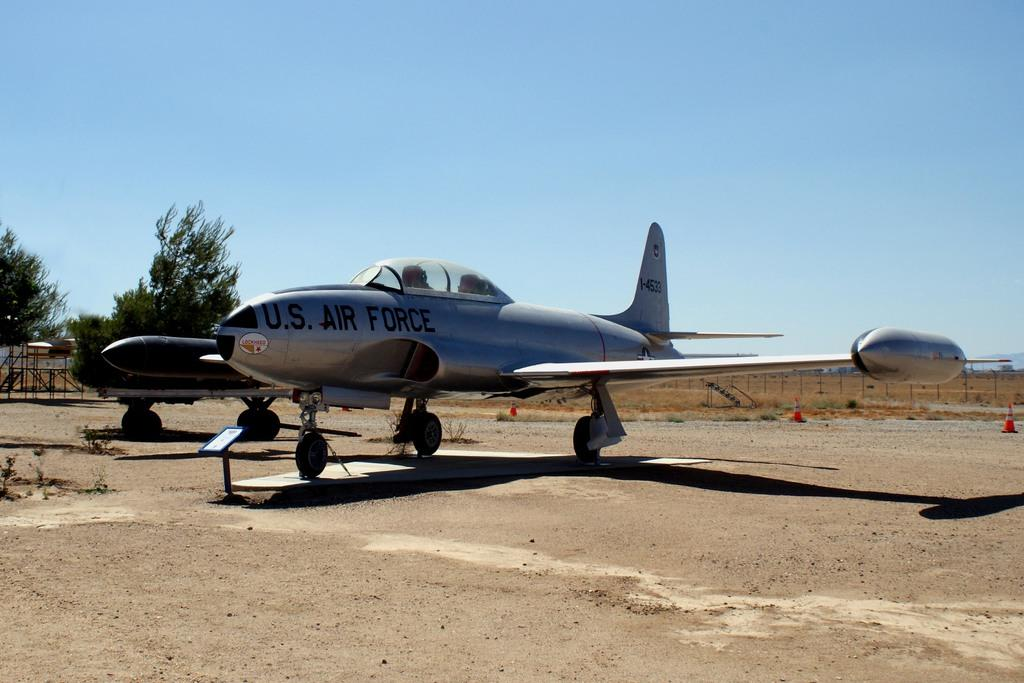Where was the image taken? The image is clicked outside. What is the main subject of the image? The main subject of the image is an airplane. What are the features of the airplane in the image? The airplane has wings, wheels, and a propeller. What can be seen on the left side of the image? There are trees on the left side of the image. What is visible at the top of the image? The sky is visible at the top of the image. What type of pest can be seen crawling on the airplane in the image? There are no pests visible on the airplane in the image. Can you tell me how many basketballs are present in the image? There are no basketballs present in the image. 